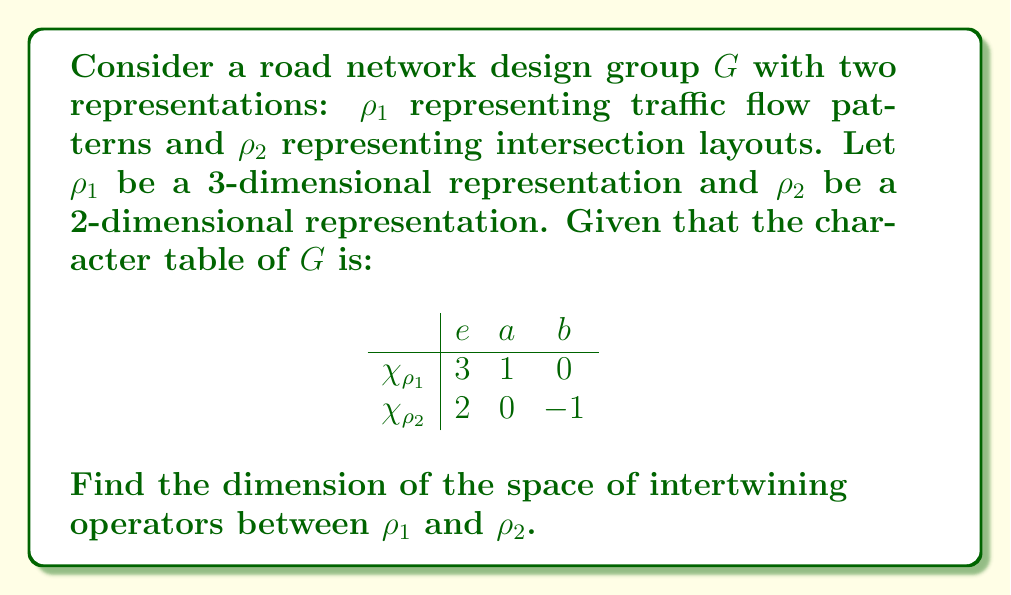Show me your answer to this math problem. To find the dimension of the space of intertwining operators between two representations $\rho_1$ and $\rho_2$, we can use the following steps:

1) The dimension is given by the formula:

   $$\dim \text{Hom}_G(\rho_1, \rho_2) = \frac{1}{|G|} \sum_{g \in G} \chi_{\rho_1}(g) \overline{\chi_{\rho_2}(g)}$$

   where $\chi_{\rho_1}$ and $\chi_{\rho_2}$ are the characters of $\rho_1$ and $\rho_2$ respectively, and $|G|$ is the order of the group.

2) From the character table, we can see that $|G| = 3$ (the number of conjugacy classes).

3) Let's calculate the sum:

   For $e$: $\chi_{\rho_1}(e) \overline{\chi_{\rho_2}(e)} = 3 \cdot 2 = 6$
   For $a$: $\chi_{\rho_1}(a) \overline{\chi_{\rho_2}(a)} = 1 \cdot 0 = 0$
   For $b$: $\chi_{\rho_1}(b) \overline{\chi_{\rho_2}(b)} = 0 \cdot (-1) = 0$

4) The sum is therefore $6 + 0 + 0 = 6$

5) Applying the formula:

   $$\dim \text{Hom}_G(\rho_1, \rho_2) = \frac{1}{3} \cdot 6 = 2$$

Thus, the dimension of the space of intertwining operators between $\rho_1$ and $\rho_2$ is 2.
Answer: 2 